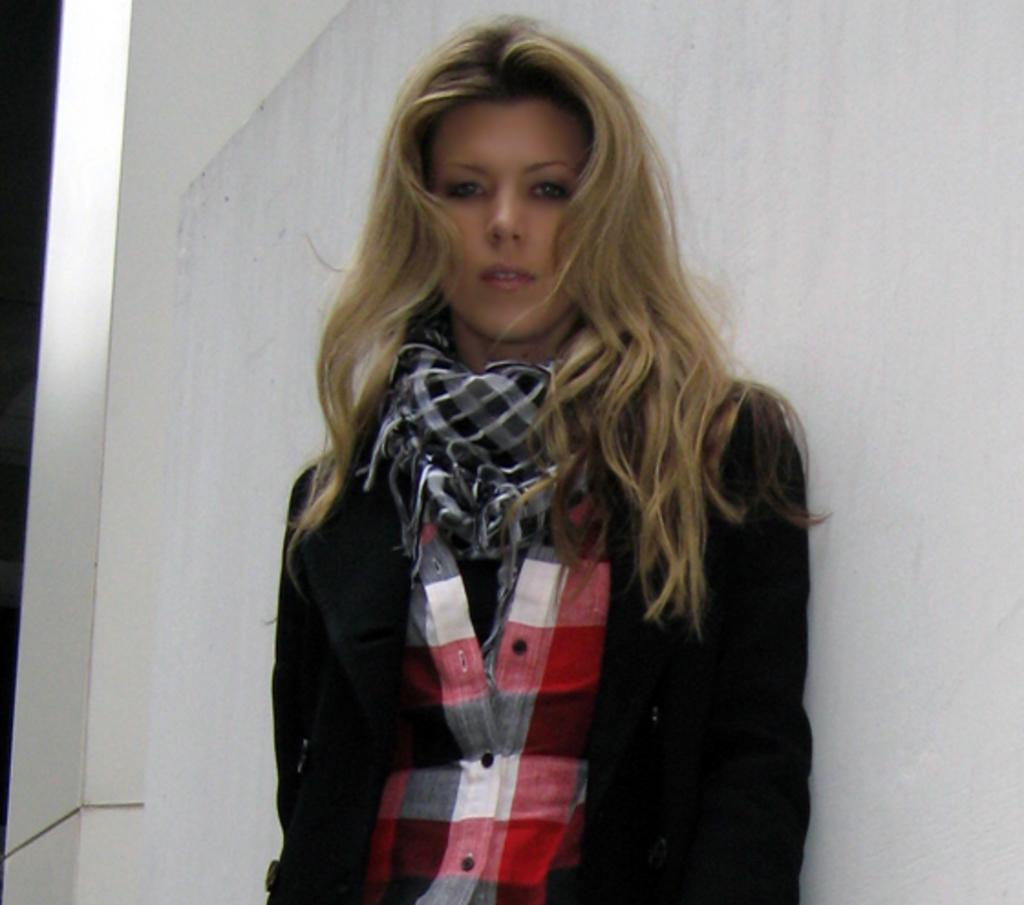Who is in the image? There is a woman in the image. What is the woman wearing? The woman is wearing a black jacket and a black and white scarf. What is the woman doing in the image? The woman is standing and posing for a photo. What can be seen in the background of the image? There is a white wall in the background of the image. How many cherries are on the woman's head in the image? There are no cherries present on the woman's head in the image. Is the woman in the image in a quiet environment? The image does not provide information about the noise level in the environment, so it cannot be determined whether it is quiet or not. 